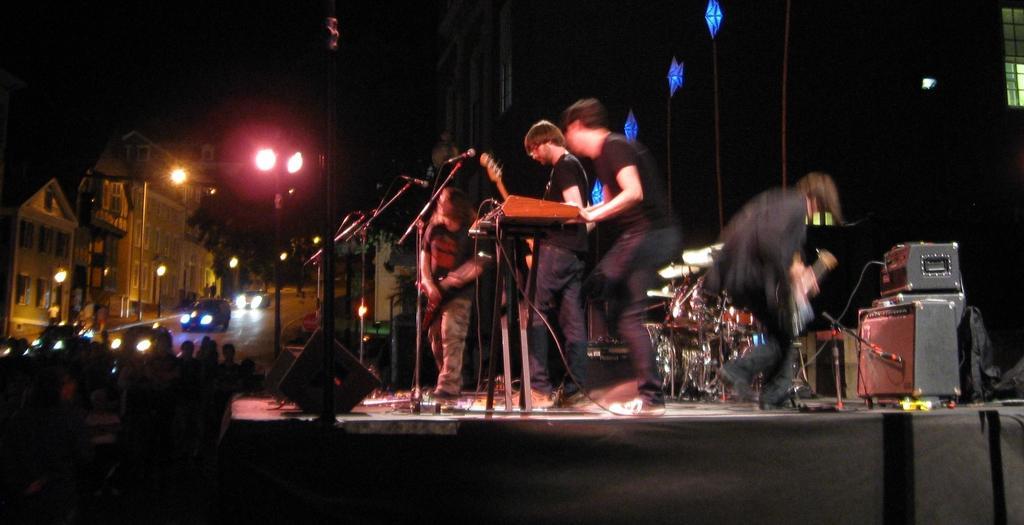Could you give a brief overview of what you see in this image? Here it's a stage three people are standing on the stage. These 2 are boys and this is a girl. Here it's a microphone and guitar behind them there are some musical instruments. The left side of an image there is a road you can see the vehicles on it. These are the streetlights, these are the buildings. 